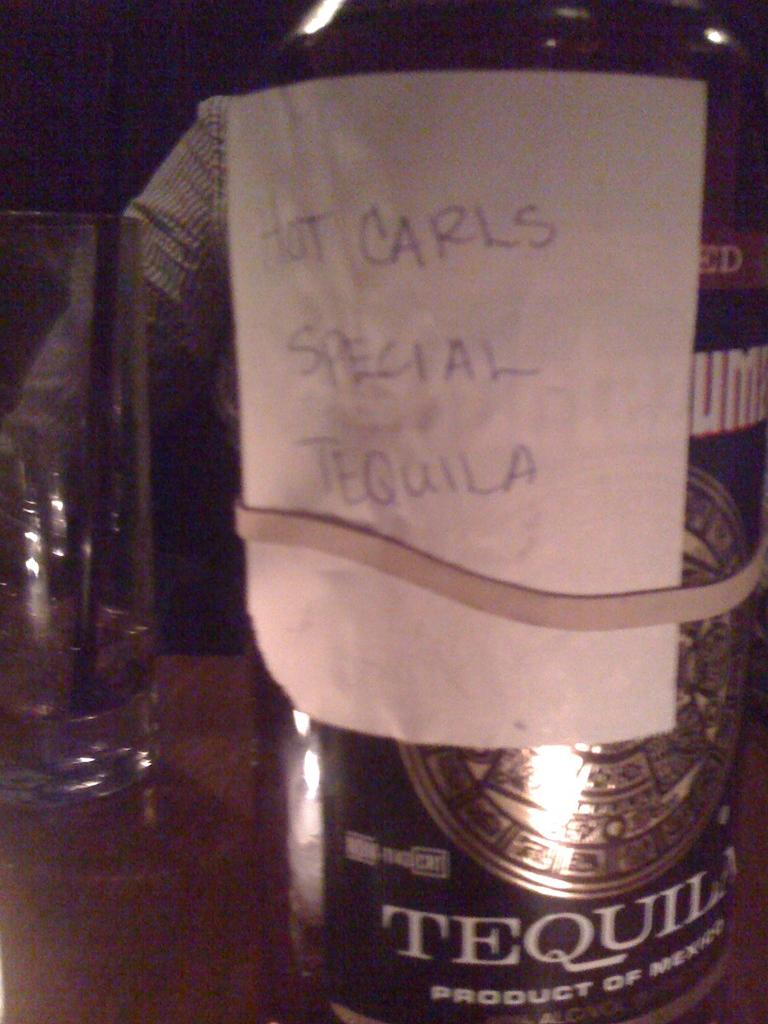<image>
Offer a succinct explanation of the picture presented. A bottle has a hand written note attached to it designating it as Carl's tequila. 